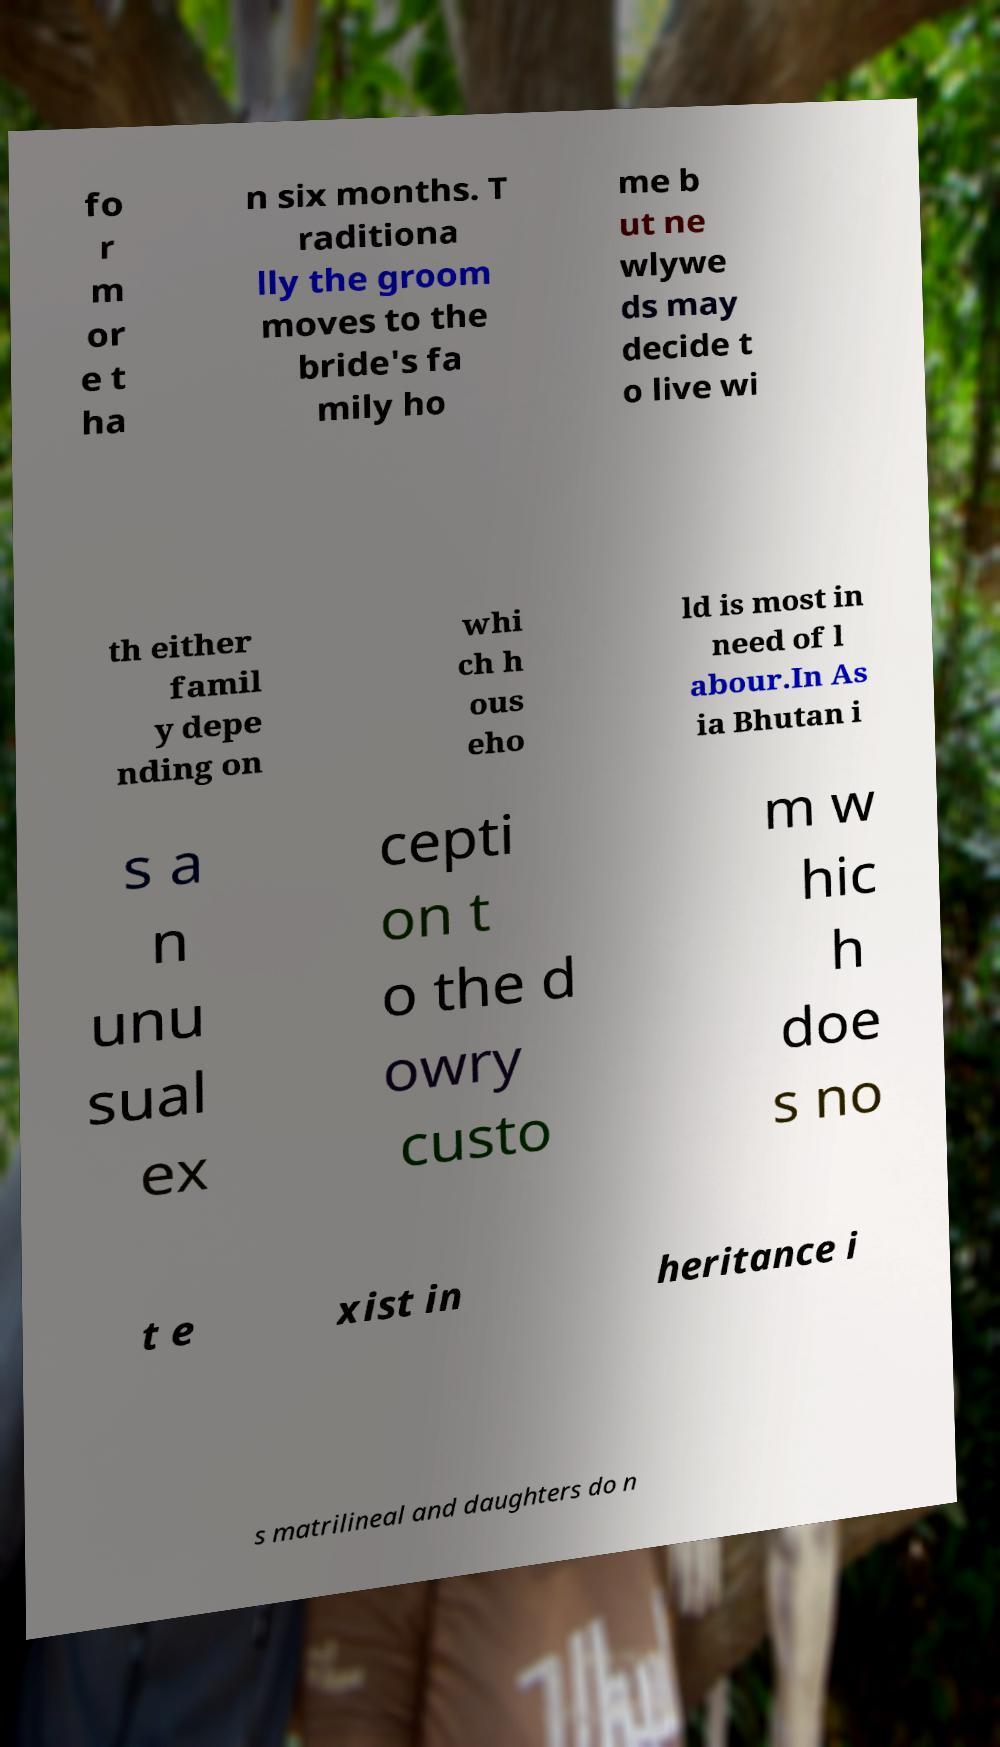There's text embedded in this image that I need extracted. Can you transcribe it verbatim? fo r m or e t ha n six months. T raditiona lly the groom moves to the bride's fa mily ho me b ut ne wlywe ds may decide t o live wi th either famil y depe nding on whi ch h ous eho ld is most in need of l abour.In As ia Bhutan i s a n unu sual ex cepti on t o the d owry custo m w hic h doe s no t e xist in heritance i s matrilineal and daughters do n 